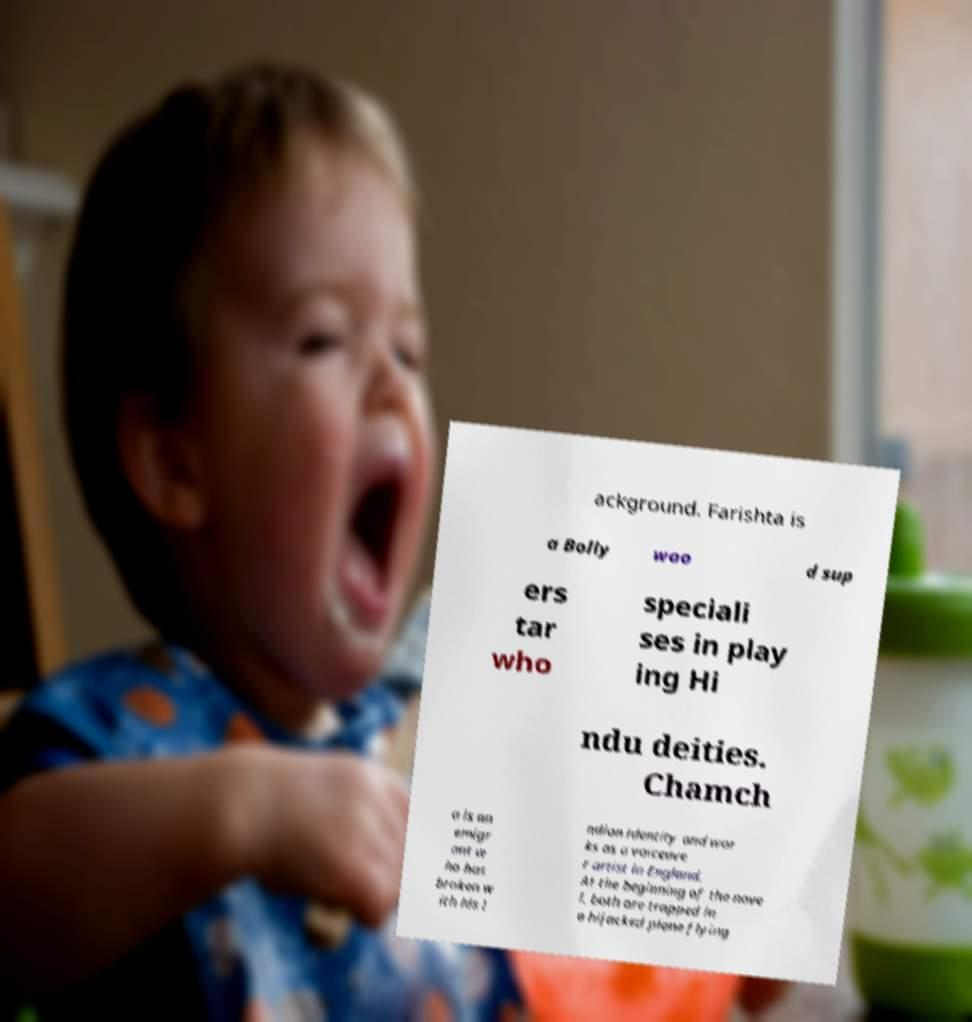Please read and relay the text visible in this image. What does it say? ackground. Farishta is a Bolly woo d sup ers tar who speciali ses in play ing Hi ndu deities. Chamch a is an emigr ant w ho has broken w ith his I ndian identity and wor ks as a voiceove r artist in England. At the beginning of the nove l, both are trapped in a hijacked plane flying 